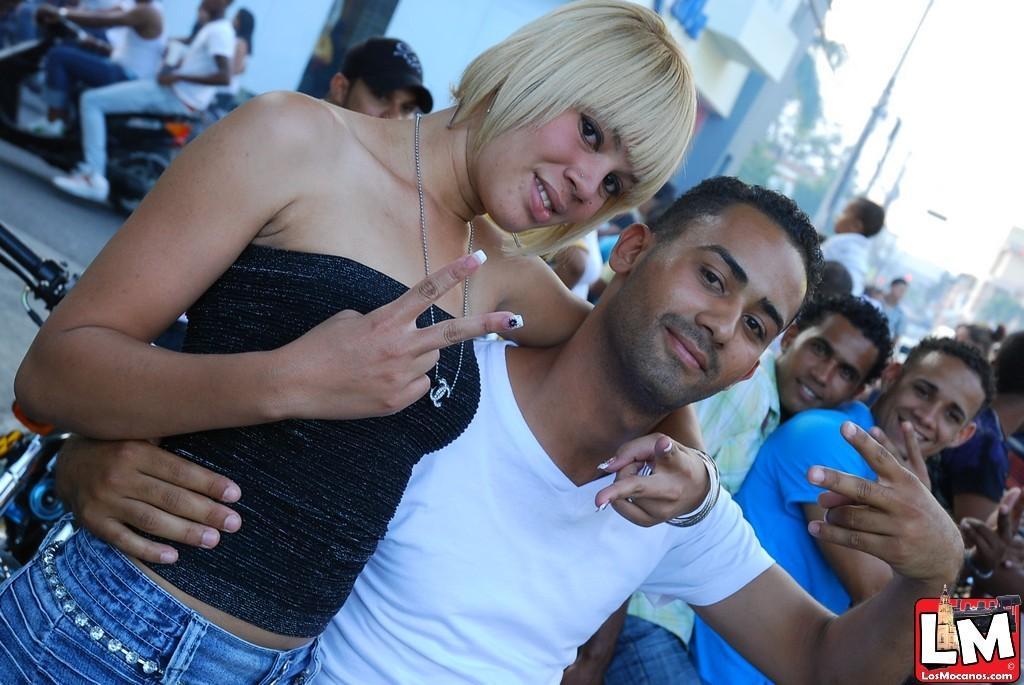Can you describe this image briefly? In this image I can see group of people. In front the person is wearing black and blue color dress. In the background I can see few poles, buildings and the sky is in white color. 